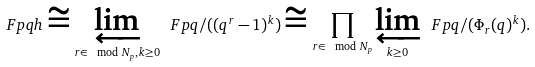<formula> <loc_0><loc_0><loc_500><loc_500>\ F p q h \cong \varprojlim _ { r \in \mod N _ { p } , k \geq 0 } \ F p q / ( ( q ^ { r } - 1 ) ^ { k } ) \cong \prod _ { r \in \mod N _ { p } } \varprojlim _ { k \geq 0 } \ F p q / ( \Phi _ { r } ( q ) ^ { k } ) .</formula> 